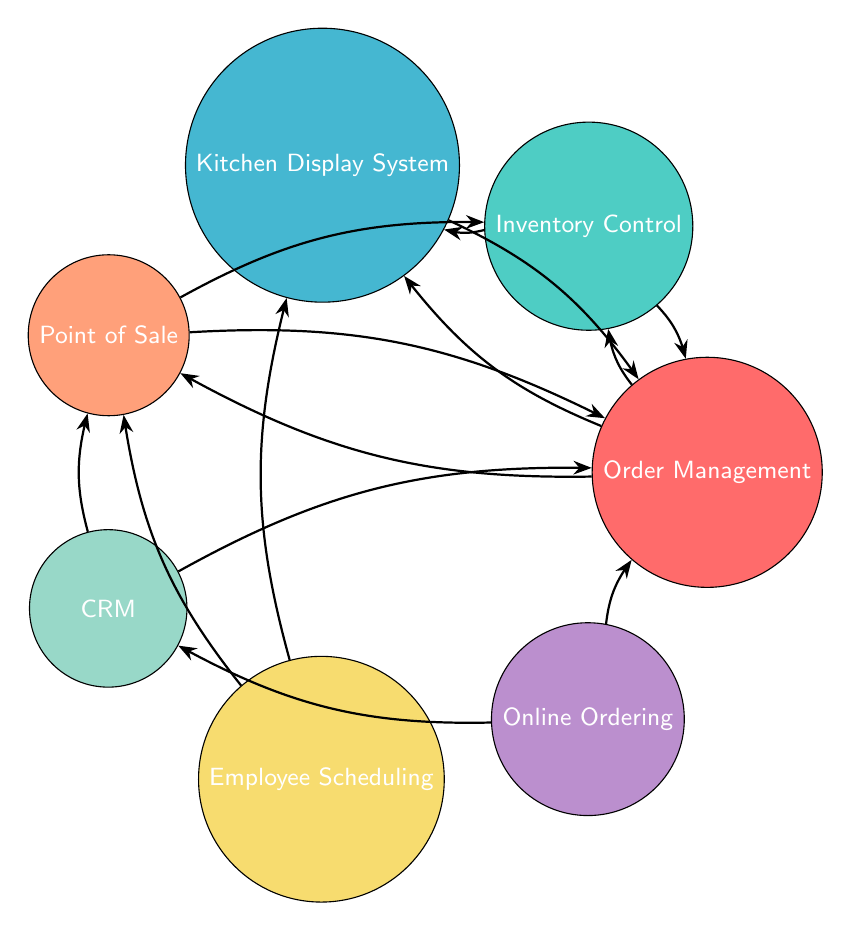What are the total number of nodes in the diagram? By counting each unique module represented in the diagram, we can see that there are seven distinct nodes labeled as Order Management, Inventory Control, Kitchen Display System, Point of Sale, Customer Relationship Management, Employee Scheduling, and Online Ordering. Thus, the total number of nodes is 7.
Answer: 7 Which node connects the Kitchen Display System and Order Management? Referring to the edges in the diagram, it's evident that there is a direct connection (link) from the Kitchen Display System to Order Management and vice versa, establishing that Order Management connects both.
Answer: Order Management How many edges are connected to the Point of Sale node? By reviewing the connections/edges associated with the Point of Sale node, we see that it links to Order Management, Inventory Control, Customer Relationship Management, and Employee Scheduling, totaling four edges connected to it.
Answer: 4 Which module acts as an entry point for online orders? The Online Ordering node connects to the Order Management node, indicating that Order Management serves as the entry point for online orders within the system.
Answer: Order Management What common function is shared between Customer Relationship Management and Point of Sale? Both the Customer Relationship Management and Point of Sale nodes share a direct connection to one another, which signifies a flow of information or interaction functional between these two modules in the diagram.
Answer: Connection How many links does Inventory Control have that directly interact with Order Management? The Inventory Control node interacts with Order Management through two distinct links: one from Inventory Control to Order Management and another from Order Management back to Inventory Control, totaling two direct interactions.
Answer: 2 Which module is associated with Employee Scheduling? From the diagram, Employee Scheduling has connections with the Kitchen Display System and Point of Sale, indicating that it influences or is dependent on these modules in its operations.
Answer: Kitchen Display System and Point of Sale Which two nodes indicate a bi-directional relationship? Reviewing the connections in the diagram reveals that Order Management and Inventory Control, along with the connections between Order Management and Kitchen Display System, exhibit a bi-directional relationship, allowing for two-way communication or data exchange.
Answer: Order Management and Inventory Control, Kitchen Display System What is the link from Online Ordering related to? The Online Ordering module links directly to both the Order Management and Customer Relationship Management modules, which indicates its role in facilitating order processing and customer interactions.
Answer: Order Management and Customer Relationship Management 